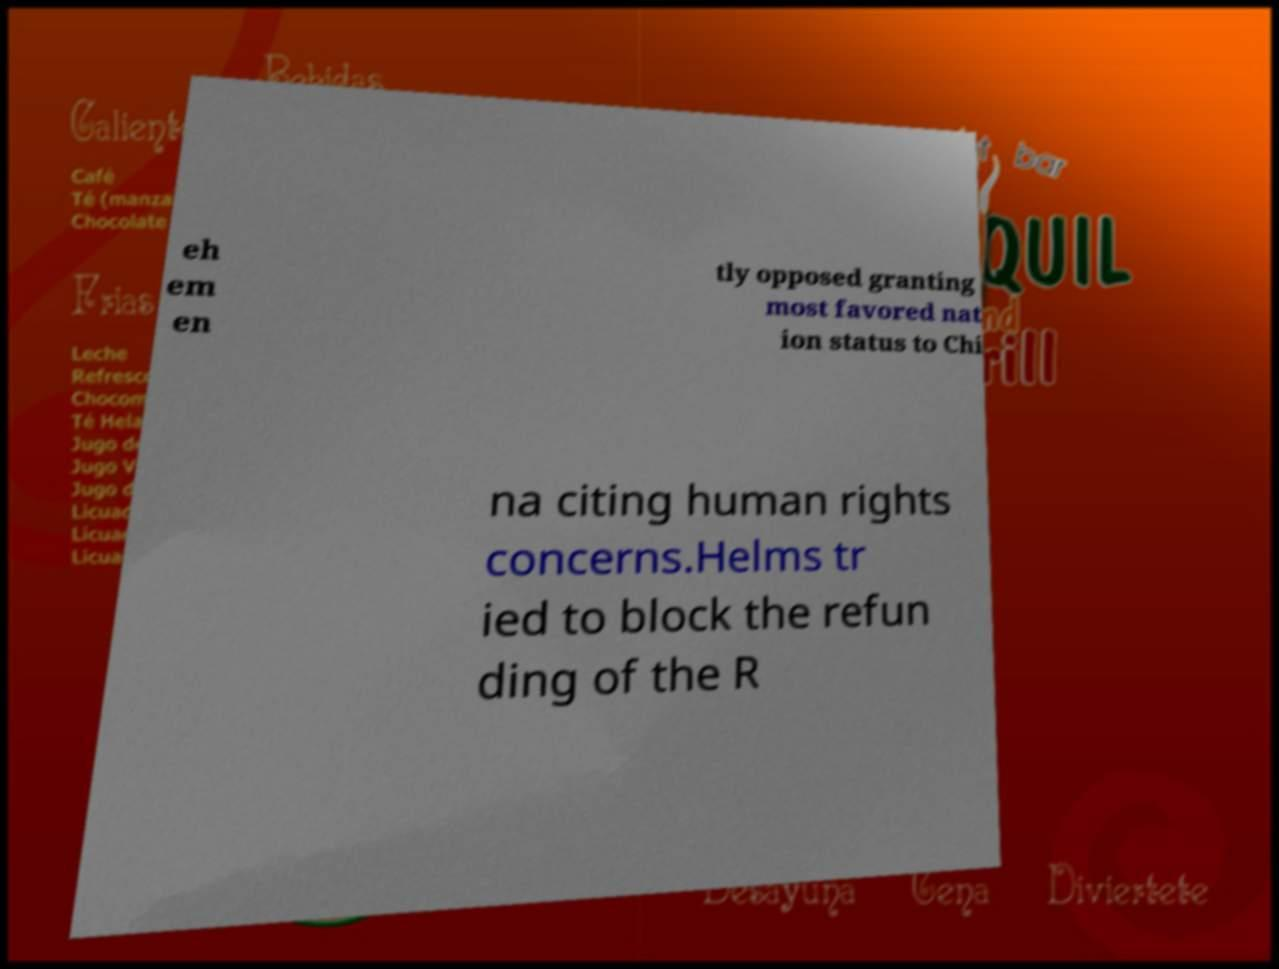Could you extract and type out the text from this image? eh em en tly opposed granting most favored nat ion status to Chi na citing human rights concerns.Helms tr ied to block the refun ding of the R 